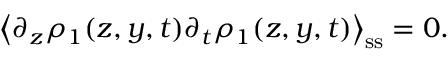<formula> <loc_0><loc_0><loc_500><loc_500>\left \langle \partial _ { z } \rho _ { 1 } ( z , y , t ) \partial _ { t } \rho _ { 1 } ( z , y , t ) \right \rangle _ { s s } = 0 .</formula> 